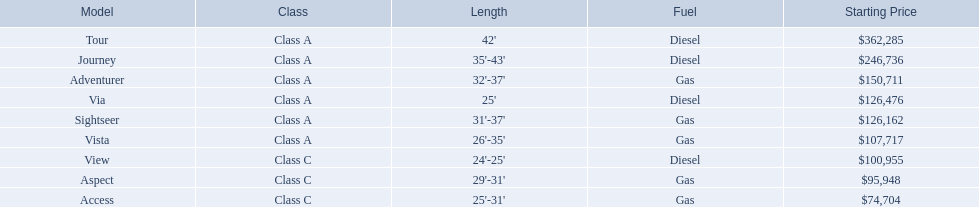What are all the class a models offered by winnebago industries? Tour, Journey, Adventurer, Via, Sightseer, Vista. Among these class a models, which has the highest base price? Tour. 